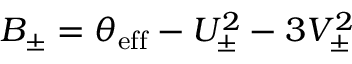Convert formula to latex. <formula><loc_0><loc_0><loc_500><loc_500>B _ { \pm } = \theta _ { e f f } - U _ { \pm } ^ { 2 } - 3 V _ { \pm } ^ { 2 }</formula> 